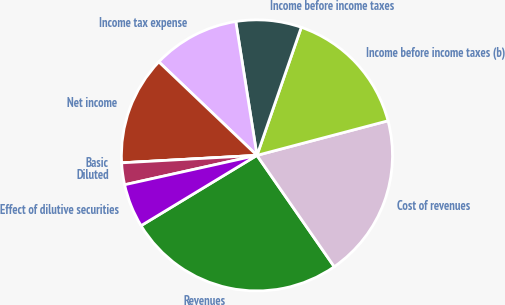Convert chart to OTSL. <chart><loc_0><loc_0><loc_500><loc_500><pie_chart><fcel>Revenues<fcel>Cost of revenues<fcel>Income before income taxes (b)<fcel>Income before income taxes<fcel>Income tax expense<fcel>Net income<fcel>Basic<fcel>Diluted<fcel>Effect of dilutive securities<nl><fcel>25.98%<fcel>19.45%<fcel>15.59%<fcel>7.8%<fcel>10.39%<fcel>12.99%<fcel>0.0%<fcel>2.6%<fcel>5.2%<nl></chart> 